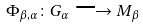Convert formula to latex. <formula><loc_0><loc_0><loc_500><loc_500>\Phi _ { \beta , \alpha } \colon G _ { \alpha } \longrightarrow M _ { \beta }</formula> 